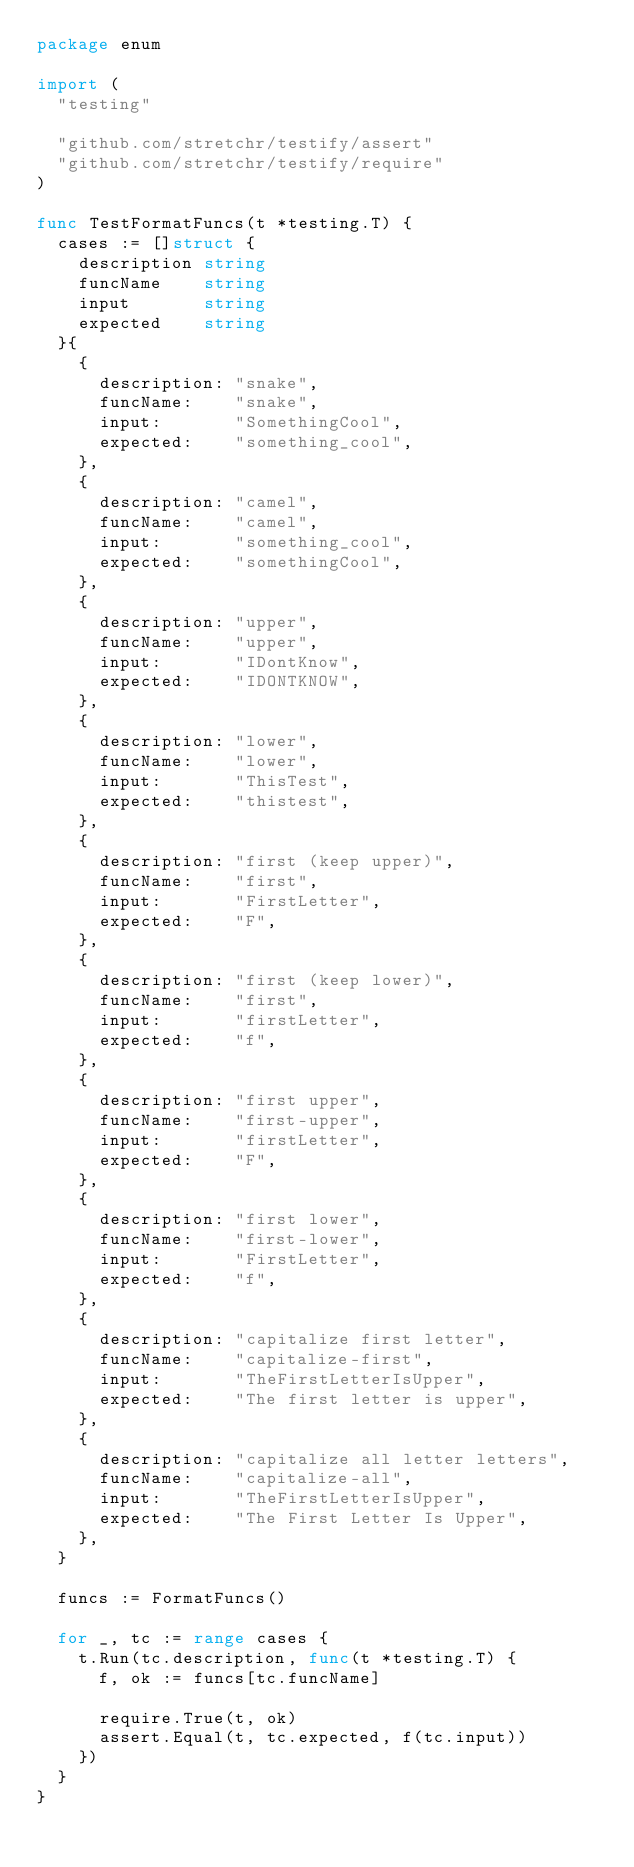<code> <loc_0><loc_0><loc_500><loc_500><_Go_>package enum

import (
	"testing"

	"github.com/stretchr/testify/assert"
	"github.com/stretchr/testify/require"
)

func TestFormatFuncs(t *testing.T) {
	cases := []struct {
		description string
		funcName    string
		input       string
		expected    string
	}{
		{
			description: "snake",
			funcName:    "snake",
			input:       "SomethingCool",
			expected:    "something_cool",
		},
		{
			description: "camel",
			funcName:    "camel",
			input:       "something_cool",
			expected:    "somethingCool",
		},
		{
			description: "upper",
			funcName:    "upper",
			input:       "IDontKnow",
			expected:    "IDONTKNOW",
		},
		{
			description: "lower",
			funcName:    "lower",
			input:       "ThisTest",
			expected:    "thistest",
		},
		{
			description: "first (keep upper)",
			funcName:    "first",
			input:       "FirstLetter",
			expected:    "F",
		},
		{
			description: "first (keep lower)",
			funcName:    "first",
			input:       "firstLetter",
			expected:    "f",
		},
		{
			description: "first upper",
			funcName:    "first-upper",
			input:       "firstLetter",
			expected:    "F",
		},
		{
			description: "first lower",
			funcName:    "first-lower",
			input:       "FirstLetter",
			expected:    "f",
		},
		{
			description: "capitalize first letter",
			funcName:    "capitalize-first",
			input:       "TheFirstLetterIsUpper",
			expected:    "The first letter is upper",
		},
		{
			description: "capitalize all letter letters",
			funcName:    "capitalize-all",
			input:       "TheFirstLetterIsUpper",
			expected:    "The First Letter Is Upper",
		},
	}

	funcs := FormatFuncs()

	for _, tc := range cases {
		t.Run(tc.description, func(t *testing.T) {
			f, ok := funcs[tc.funcName]

			require.True(t, ok)
			assert.Equal(t, tc.expected, f(tc.input))
		})
	}
}
</code> 